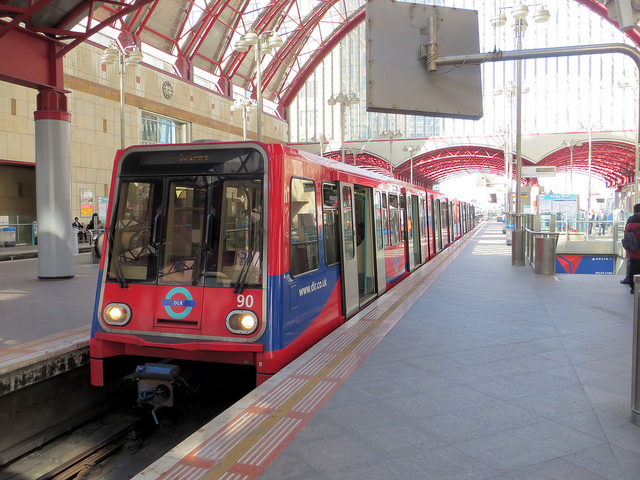Identify the text displayed in this image. 90 